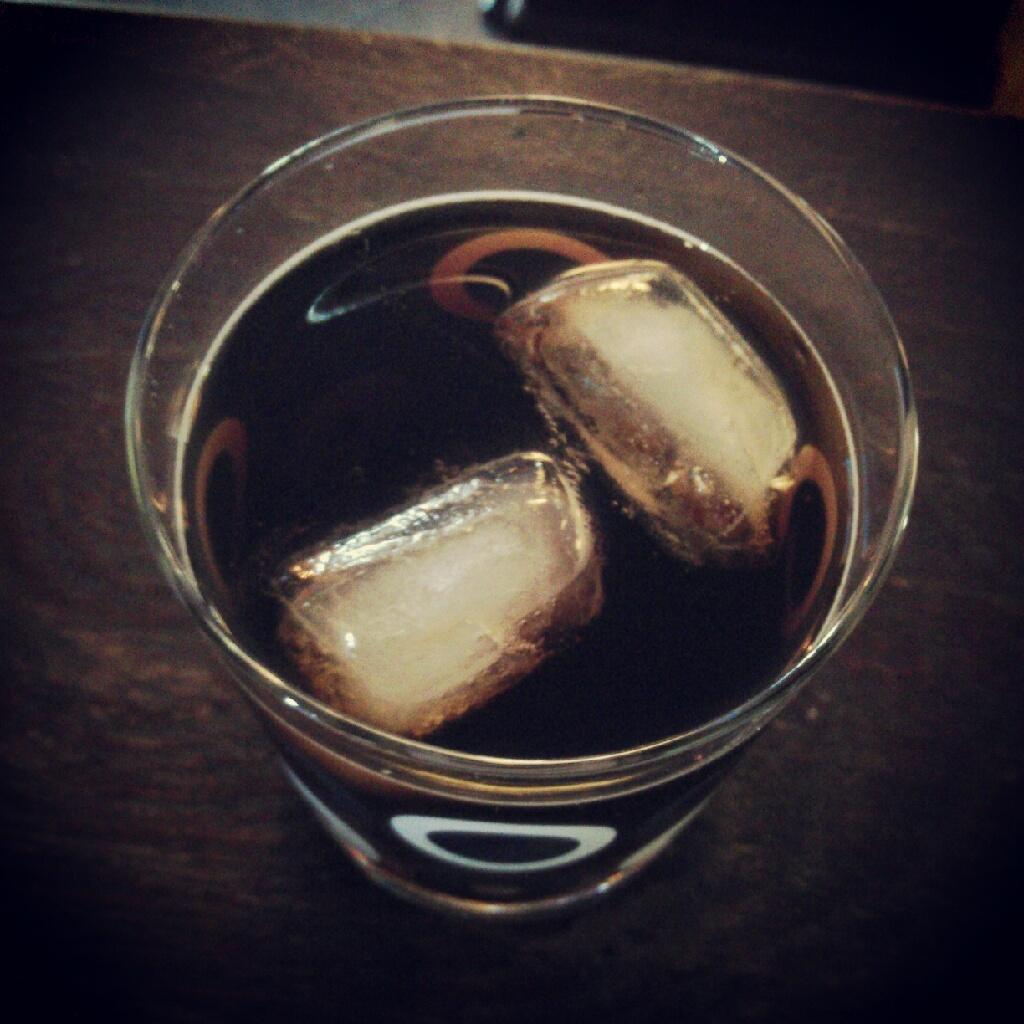Describe this image in one or two sentences. In this image we can see a glass containing ice cubes and beverage. At the bottom there is a table. 